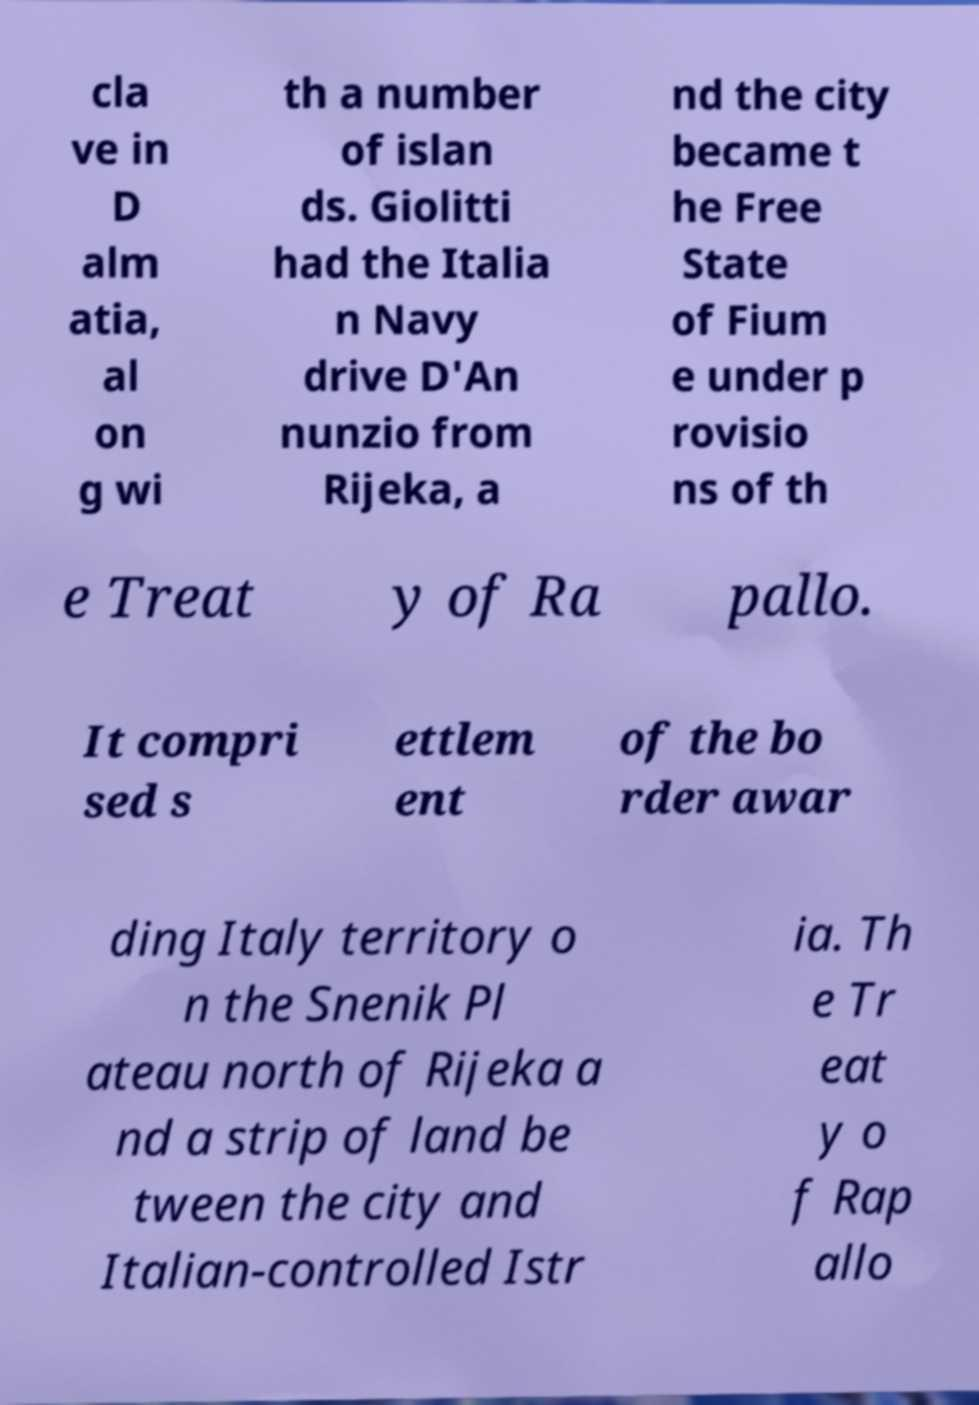What messages or text are displayed in this image? I need them in a readable, typed format. cla ve in D alm atia, al on g wi th a number of islan ds. Giolitti had the Italia n Navy drive D'An nunzio from Rijeka, a nd the city became t he Free State of Fium e under p rovisio ns of th e Treat y of Ra pallo. It compri sed s ettlem ent of the bo rder awar ding Italy territory o n the Snenik Pl ateau north of Rijeka a nd a strip of land be tween the city and Italian-controlled Istr ia. Th e Tr eat y o f Rap allo 